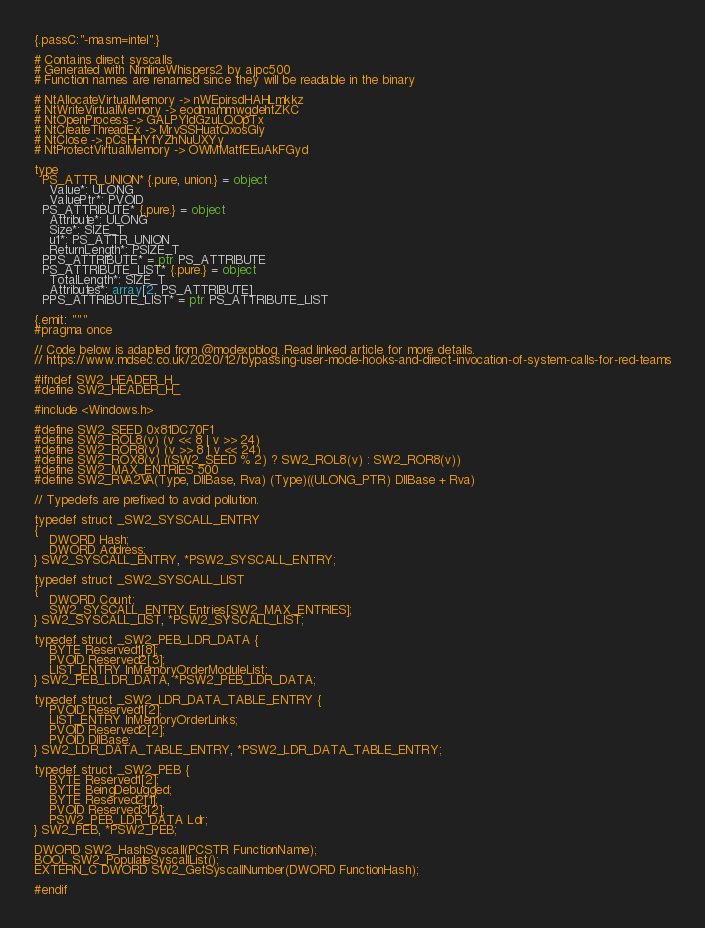<code> <loc_0><loc_0><loc_500><loc_500><_Nim_>{.passC:"-masm=intel".}

# Contains direct syscalls
# Generated with NimlineWhispers2 by ajpc500
# Function names are renamed since they will be readable in the binary

# NtAllocateVirtualMemory -> nWEpirsdHAHLmkkz
# NtWriteVirtualMemory -> eodmammwgdehtZKC
# NtOpenProcess -> GALPYIdGzuLQOpTx
# NtCreateThreadEx -> MrvSSHuatQxosGly
# NtClose -> pCsHHYfYZhNuUXYy
# NtProtectVirtualMemory -> OWMMatfEEuAkFGyd

type
  PS_ATTR_UNION* {.pure, union.} = object
    Value*: ULONG
    ValuePtr*: PVOID
  PS_ATTRIBUTE* {.pure.} = object
    Attribute*: ULONG 
    Size*: SIZE_T
    u1*: PS_ATTR_UNION
    ReturnLength*: PSIZE_T
  PPS_ATTRIBUTE* = ptr PS_ATTRIBUTE
  PS_ATTRIBUTE_LIST* {.pure.} = object
    TotalLength*: SIZE_T
    Attributes*: array[2, PS_ATTRIBUTE]
  PPS_ATTRIBUTE_LIST* = ptr PS_ATTRIBUTE_LIST

{.emit: """
#pragma once

// Code below is adapted from @modexpblog. Read linked article for more details.
// https://www.mdsec.co.uk/2020/12/bypassing-user-mode-hooks-and-direct-invocation-of-system-calls-for-red-teams

#ifndef SW2_HEADER_H_
#define SW2_HEADER_H_

#include <Windows.h>

#define SW2_SEED 0x81DC70F1
#define SW2_ROL8(v) (v << 8 | v >> 24)
#define SW2_ROR8(v) (v >> 8 | v << 24)
#define SW2_ROX8(v) ((SW2_SEED % 2) ? SW2_ROL8(v) : SW2_ROR8(v))
#define SW2_MAX_ENTRIES 500
#define SW2_RVA2VA(Type, DllBase, Rva) (Type)((ULONG_PTR) DllBase + Rva)

// Typedefs are prefixed to avoid pollution.

typedef struct _SW2_SYSCALL_ENTRY
{
    DWORD Hash;
    DWORD Address;
} SW2_SYSCALL_ENTRY, *PSW2_SYSCALL_ENTRY;

typedef struct _SW2_SYSCALL_LIST
{
    DWORD Count;
    SW2_SYSCALL_ENTRY Entries[SW2_MAX_ENTRIES];
} SW2_SYSCALL_LIST, *PSW2_SYSCALL_LIST;

typedef struct _SW2_PEB_LDR_DATA {
	BYTE Reserved1[8];
	PVOID Reserved2[3];
	LIST_ENTRY InMemoryOrderModuleList;
} SW2_PEB_LDR_DATA, *PSW2_PEB_LDR_DATA;

typedef struct _SW2_LDR_DATA_TABLE_ENTRY {
	PVOID Reserved1[2];
	LIST_ENTRY InMemoryOrderLinks;
	PVOID Reserved2[2];
	PVOID DllBase;
} SW2_LDR_DATA_TABLE_ENTRY, *PSW2_LDR_DATA_TABLE_ENTRY;

typedef struct _SW2_PEB {
	BYTE Reserved1[2];
	BYTE BeingDebugged;
	BYTE Reserved2[1];
	PVOID Reserved3[2];
	PSW2_PEB_LDR_DATA Ldr;
} SW2_PEB, *PSW2_PEB;

DWORD SW2_HashSyscall(PCSTR FunctionName);
BOOL SW2_PopulateSyscallList();
EXTERN_C DWORD SW2_GetSyscallNumber(DWORD FunctionHash);

#endif

</code> 